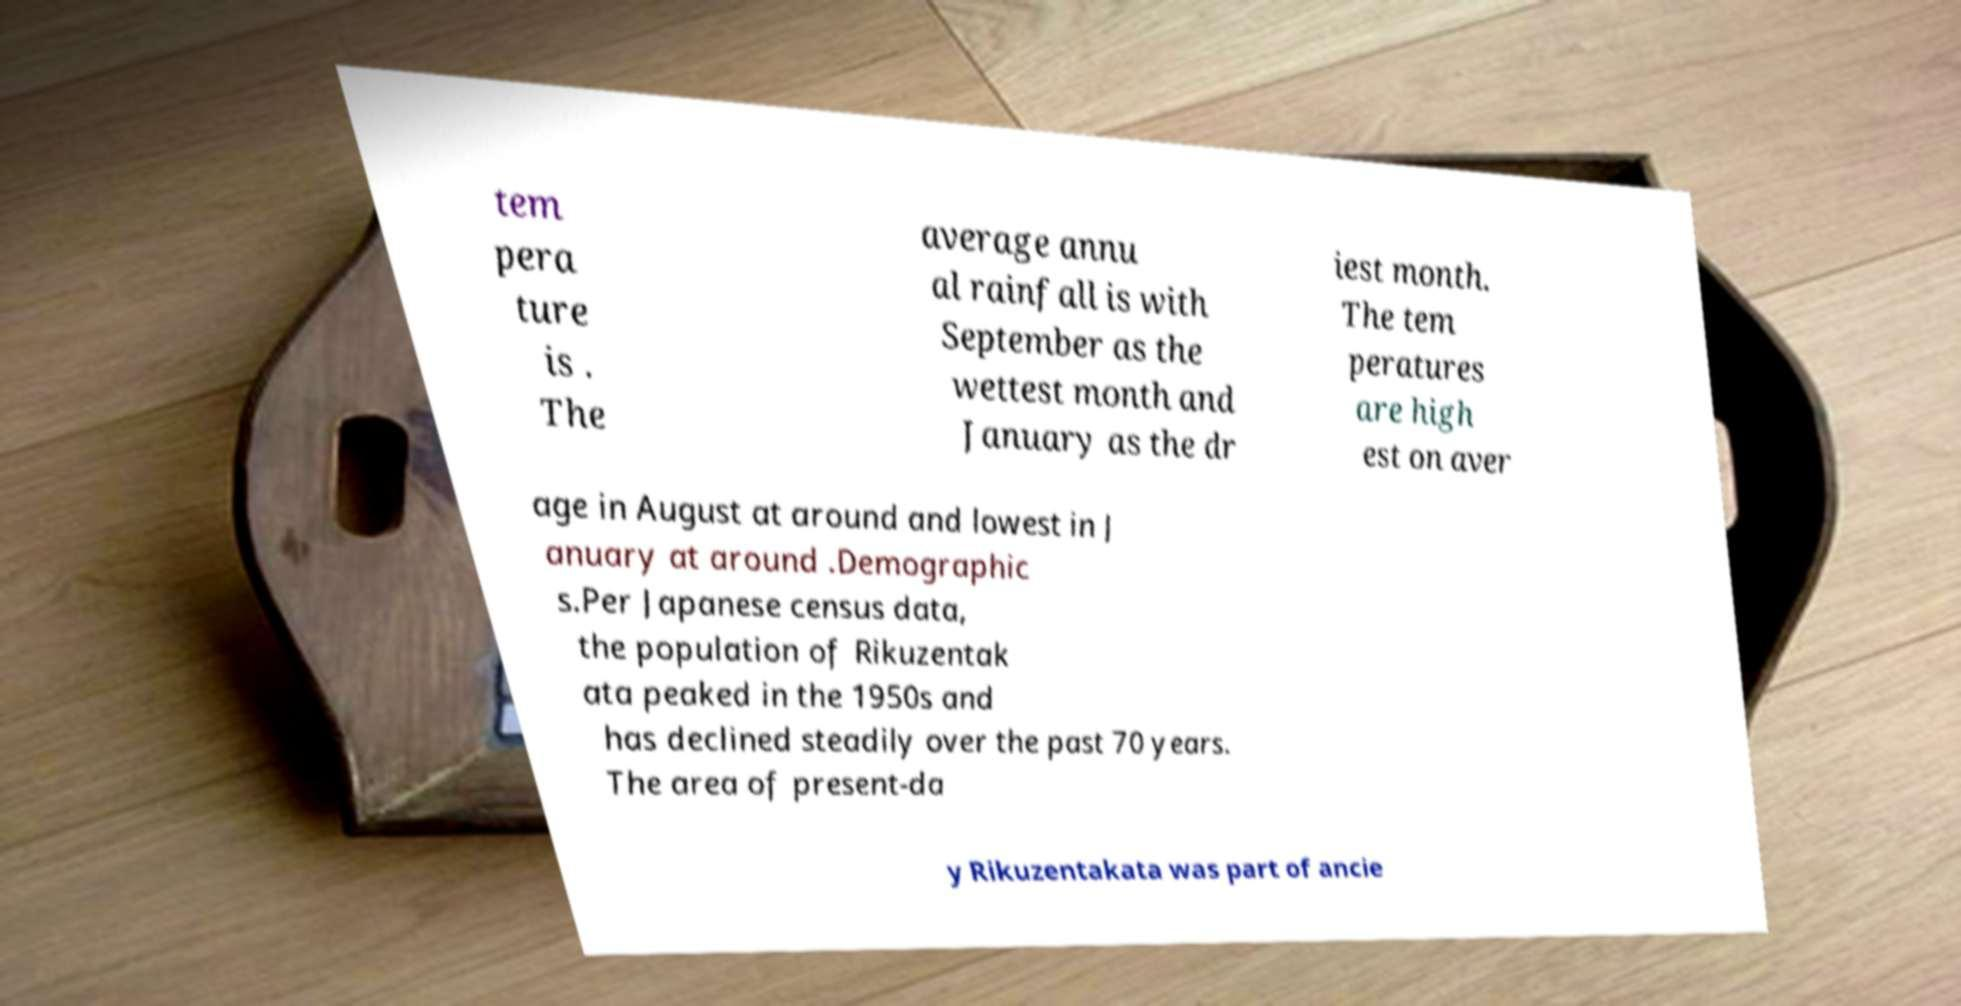There's text embedded in this image that I need extracted. Can you transcribe it verbatim? tem pera ture is . The average annu al rainfall is with September as the wettest month and January as the dr iest month. The tem peratures are high est on aver age in August at around and lowest in J anuary at around .Demographic s.Per Japanese census data, the population of Rikuzentak ata peaked in the 1950s and has declined steadily over the past 70 years. The area of present-da y Rikuzentakata was part of ancie 